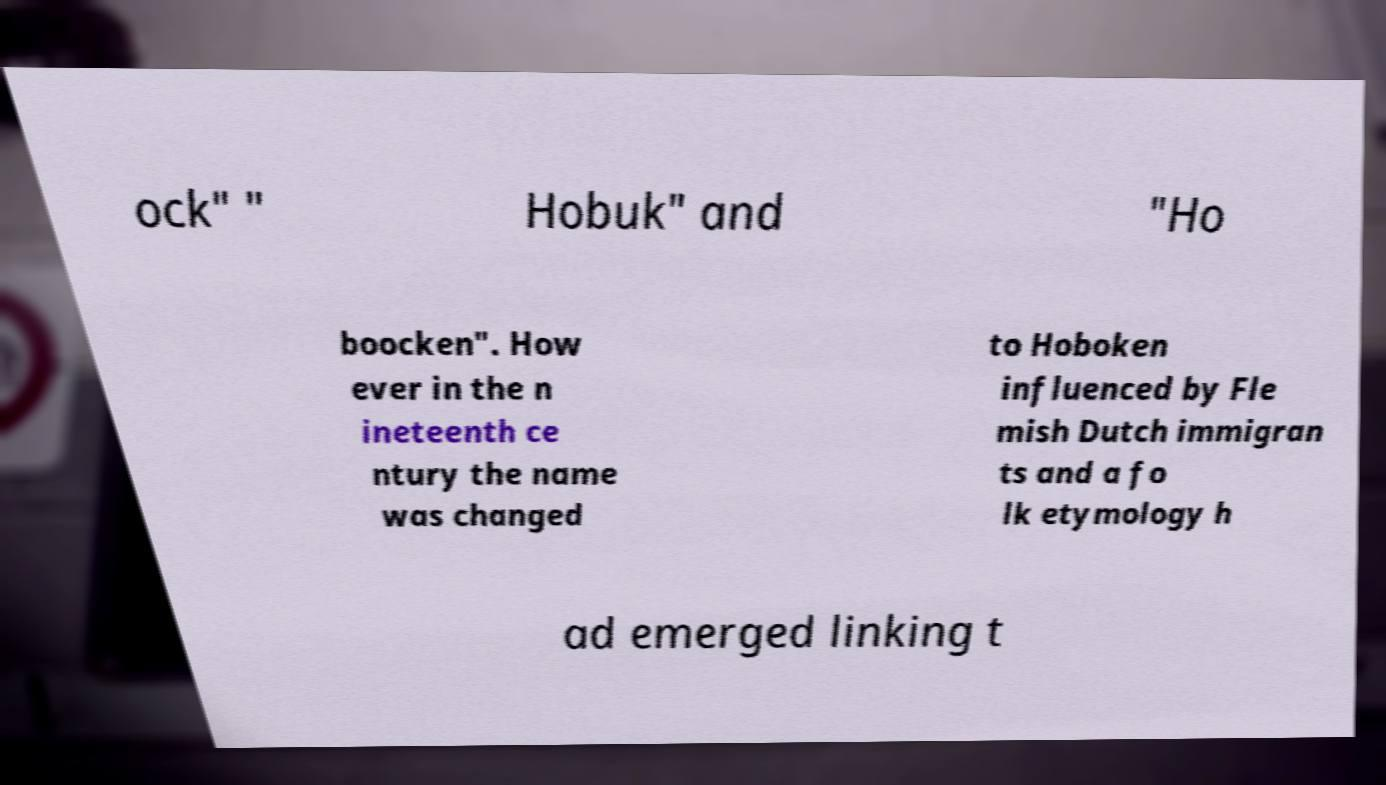Please read and relay the text visible in this image. What does it say? ock" " Hobuk" and "Ho boocken". How ever in the n ineteenth ce ntury the name was changed to Hoboken influenced by Fle mish Dutch immigran ts and a fo lk etymology h ad emerged linking t 